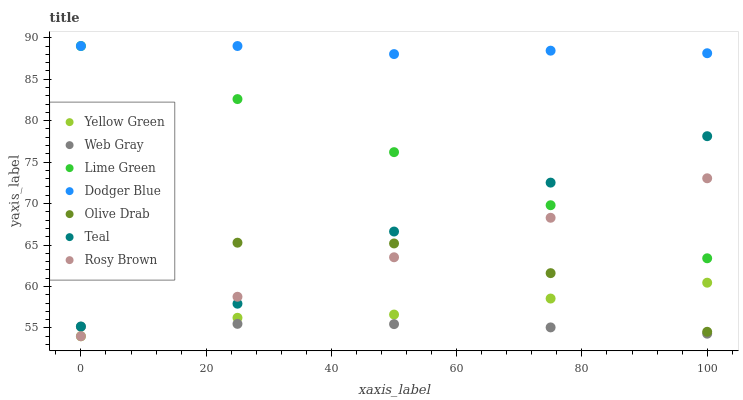Does Web Gray have the minimum area under the curve?
Answer yes or no. Yes. Does Dodger Blue have the maximum area under the curve?
Answer yes or no. Yes. Does Yellow Green have the minimum area under the curve?
Answer yes or no. No. Does Yellow Green have the maximum area under the curve?
Answer yes or no. No. Is Rosy Brown the smoothest?
Answer yes or no. Yes. Is Olive Drab the roughest?
Answer yes or no. Yes. Is Yellow Green the smoothest?
Answer yes or no. No. Is Yellow Green the roughest?
Answer yes or no. No. Does Yellow Green have the lowest value?
Answer yes or no. Yes. Does Dodger Blue have the lowest value?
Answer yes or no. No. Does Lime Green have the highest value?
Answer yes or no. Yes. Does Yellow Green have the highest value?
Answer yes or no. No. Is Web Gray less than Dodger Blue?
Answer yes or no. Yes. Is Dodger Blue greater than Teal?
Answer yes or no. Yes. Does Yellow Green intersect Olive Drab?
Answer yes or no. Yes. Is Yellow Green less than Olive Drab?
Answer yes or no. No. Is Yellow Green greater than Olive Drab?
Answer yes or no. No. Does Web Gray intersect Dodger Blue?
Answer yes or no. No. 